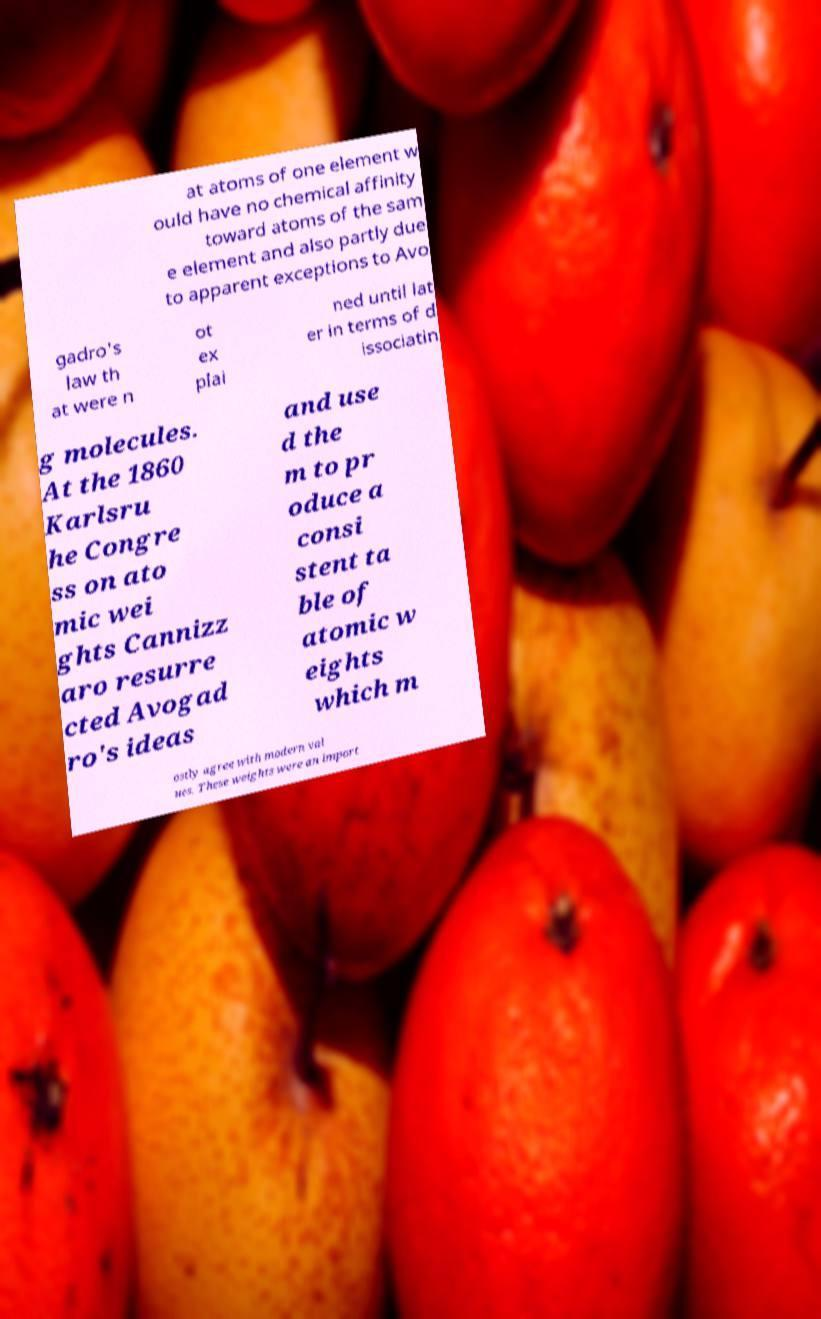I need the written content from this picture converted into text. Can you do that? at atoms of one element w ould have no chemical affinity toward atoms of the sam e element and also partly due to apparent exceptions to Avo gadro's law th at were n ot ex plai ned until lat er in terms of d issociatin g molecules. At the 1860 Karlsru he Congre ss on ato mic wei ghts Cannizz aro resurre cted Avogad ro's ideas and use d the m to pr oduce a consi stent ta ble of atomic w eights which m ostly agree with modern val ues. These weights were an import 